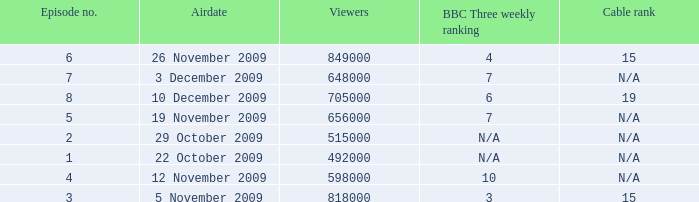Where where the bbc three weekly ranking for episode no. 5? 7.0. 